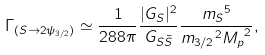<formula> <loc_0><loc_0><loc_500><loc_500>\Gamma _ { ( S \rightarrow 2 \psi _ { 3 / 2 } ) } \simeq \frac { 1 } { 2 8 8 \pi } \frac { | G _ { S } | ^ { 2 } } { G _ { S \bar { S } } } \frac { { m _ { S } } ^ { 5 } } { { m _ { 3 / 2 } } ^ { 2 } { M _ { p } } ^ { 2 } } ,</formula> 